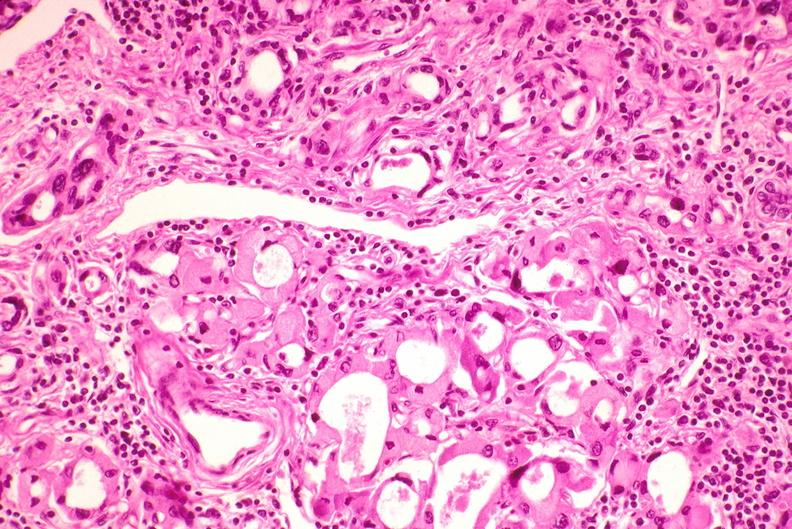s endocrine present?
Answer the question using a single word or phrase. Yes 